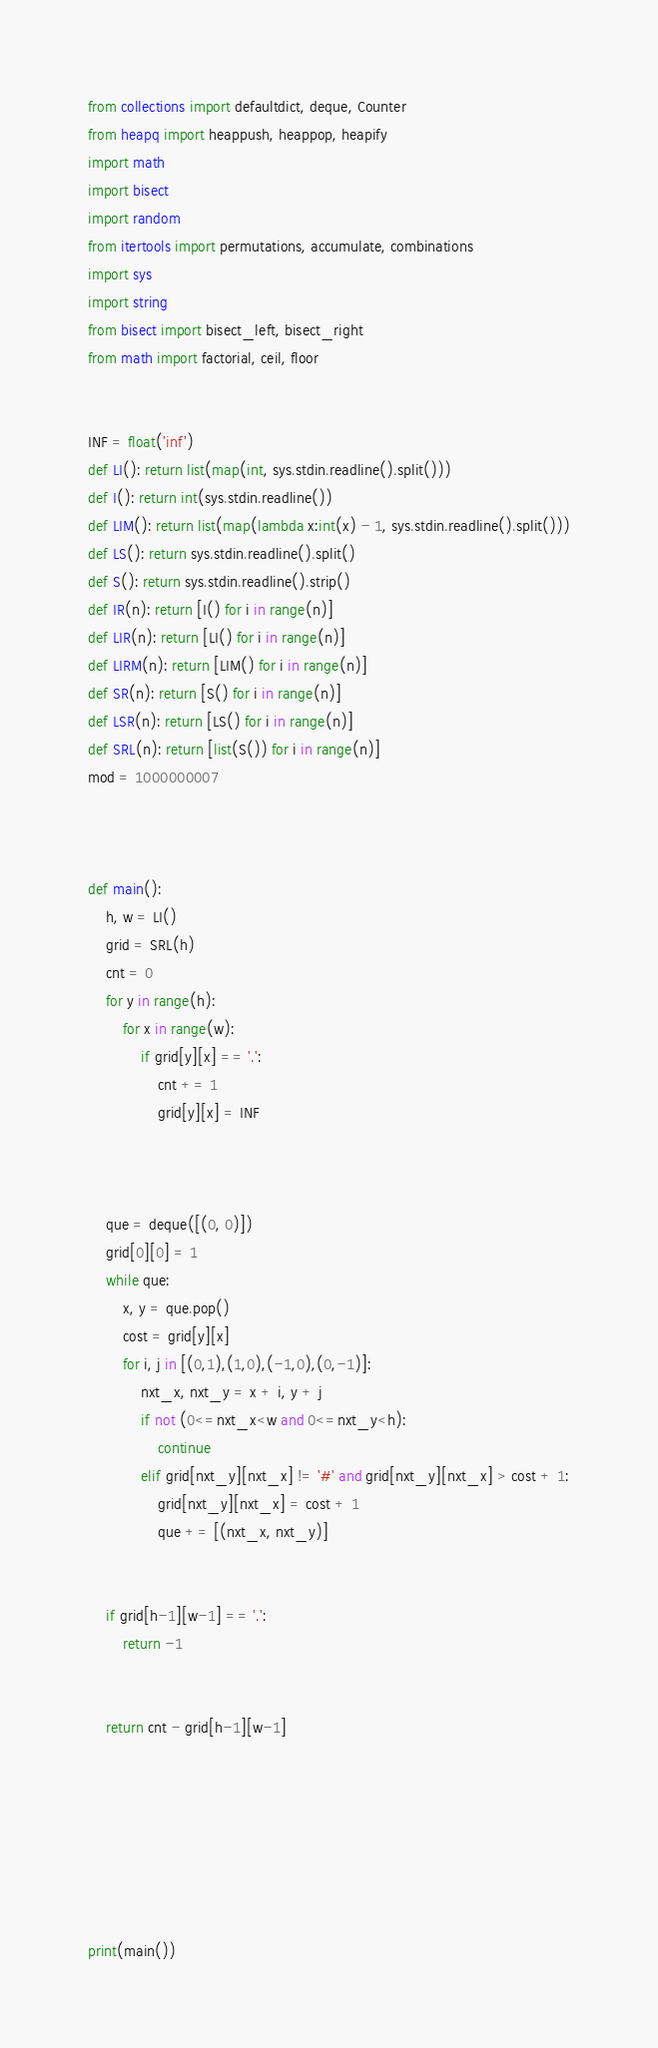<code> <loc_0><loc_0><loc_500><loc_500><_Python_>from collections import defaultdict, deque, Counter
from heapq import heappush, heappop, heapify
import math
import bisect
import random
from itertools import permutations, accumulate, combinations
import sys
import string
from bisect import bisect_left, bisect_right
from math import factorial, ceil, floor


INF = float('inf')
def LI(): return list(map(int, sys.stdin.readline().split()))
def I(): return int(sys.stdin.readline())
def LIM(): return list(map(lambda x:int(x) - 1, sys.stdin.readline().split()))
def LS(): return sys.stdin.readline().split()
def S(): return sys.stdin.readline().strip()
def IR(n): return [I() for i in range(n)]
def LIR(n): return [LI() for i in range(n)]
def LIRM(n): return [LIM() for i in range(n)]
def SR(n): return [S() for i in range(n)]
def LSR(n): return [LS() for i in range(n)]
def SRL(n): return [list(S()) for i in range(n)]
mod = 1000000007



def main():
    h, w = LI()
    grid = SRL(h)
    cnt = 0
    for y in range(h):
        for x in range(w):
            if grid[y][x] == '.':
                cnt += 1
                grid[y][x] = INF



    que = deque([(0, 0)])
    grid[0][0] = 1
    while que:
        x, y = que.pop()
        cost = grid[y][x]
        for i, j in [(0,1),(1,0),(-1,0),(0,-1)]:
            nxt_x, nxt_y = x + i, y + j
            if not (0<=nxt_x<w and 0<=nxt_y<h):
                continue
            elif grid[nxt_y][nxt_x] != '#' and grid[nxt_y][nxt_x] > cost + 1:
                grid[nxt_y][nxt_x] = cost + 1
                que += [(nxt_x, nxt_y)]


    if grid[h-1][w-1] == '.':
        return -1


    return cnt - grid[h-1][w-1]







print(main())</code> 